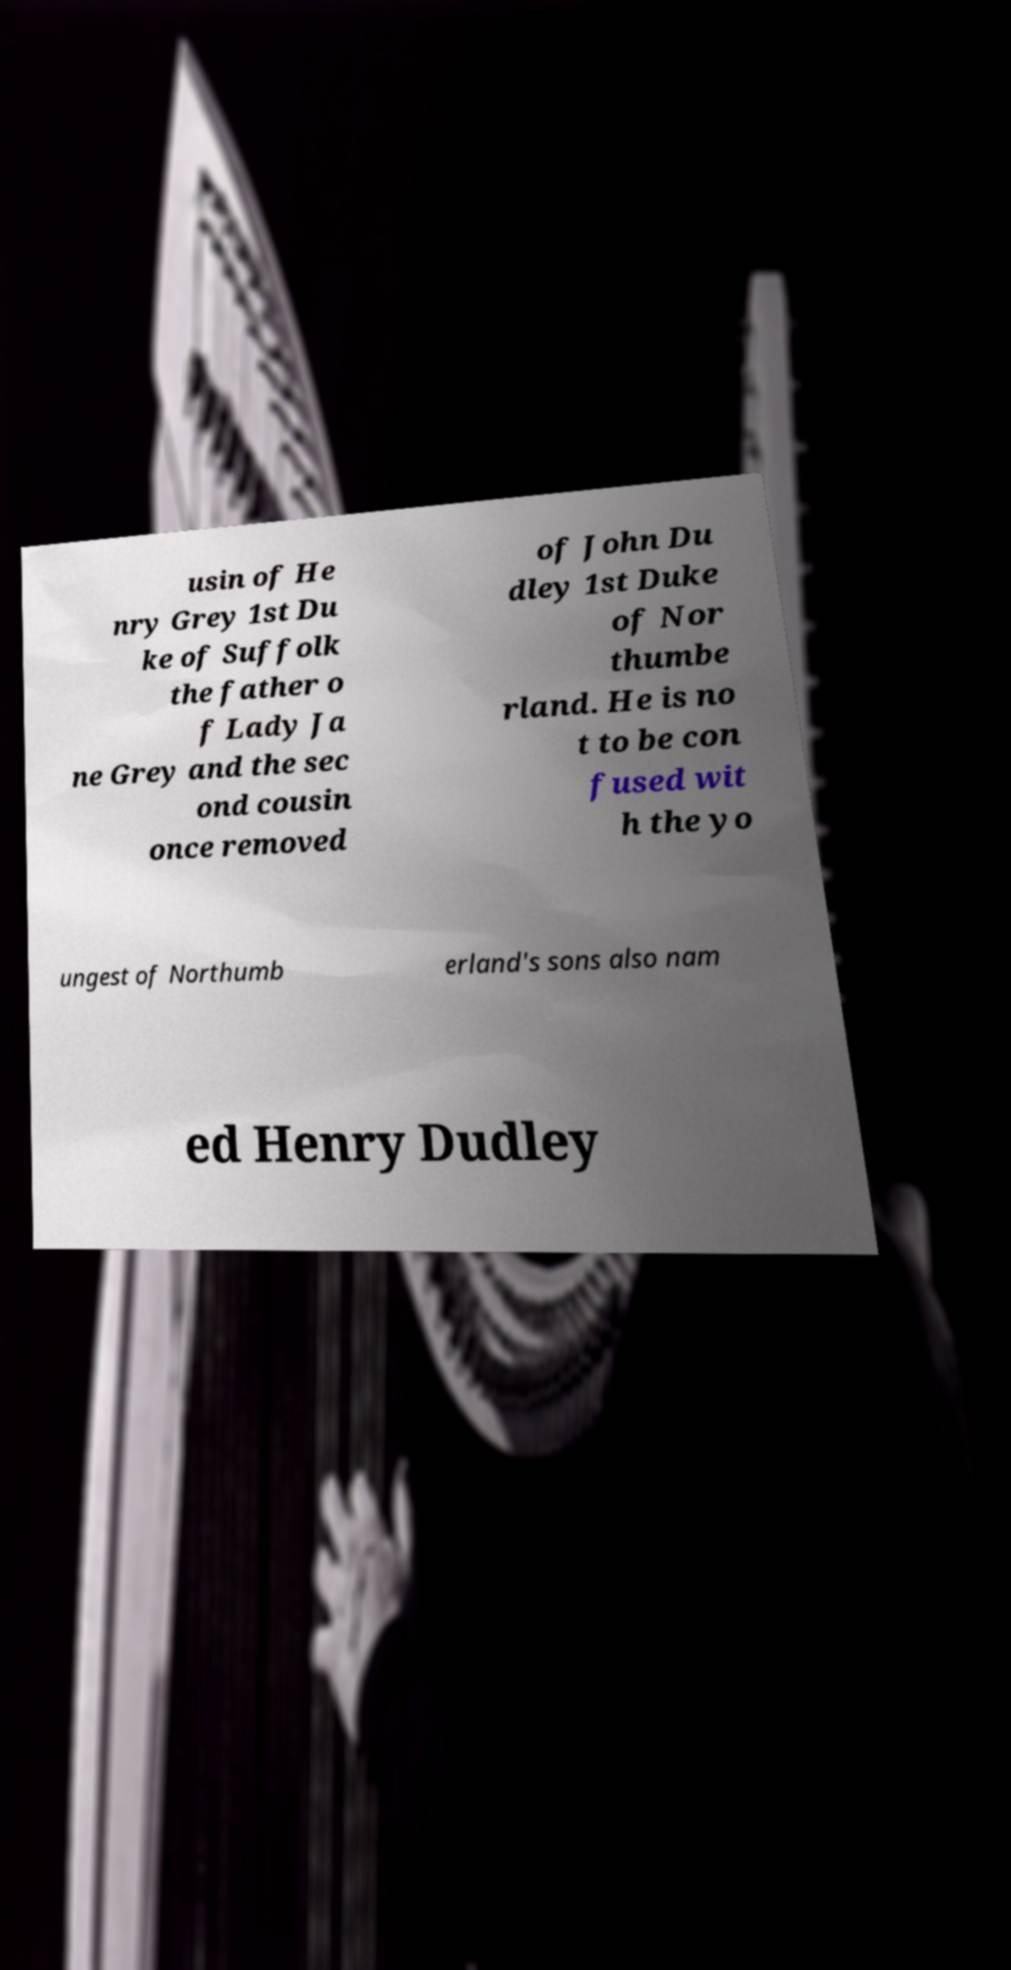Can you read and provide the text displayed in the image?This photo seems to have some interesting text. Can you extract and type it out for me? usin of He nry Grey 1st Du ke of Suffolk the father o f Lady Ja ne Grey and the sec ond cousin once removed of John Du dley 1st Duke of Nor thumbe rland. He is no t to be con fused wit h the yo ungest of Northumb erland's sons also nam ed Henry Dudley 